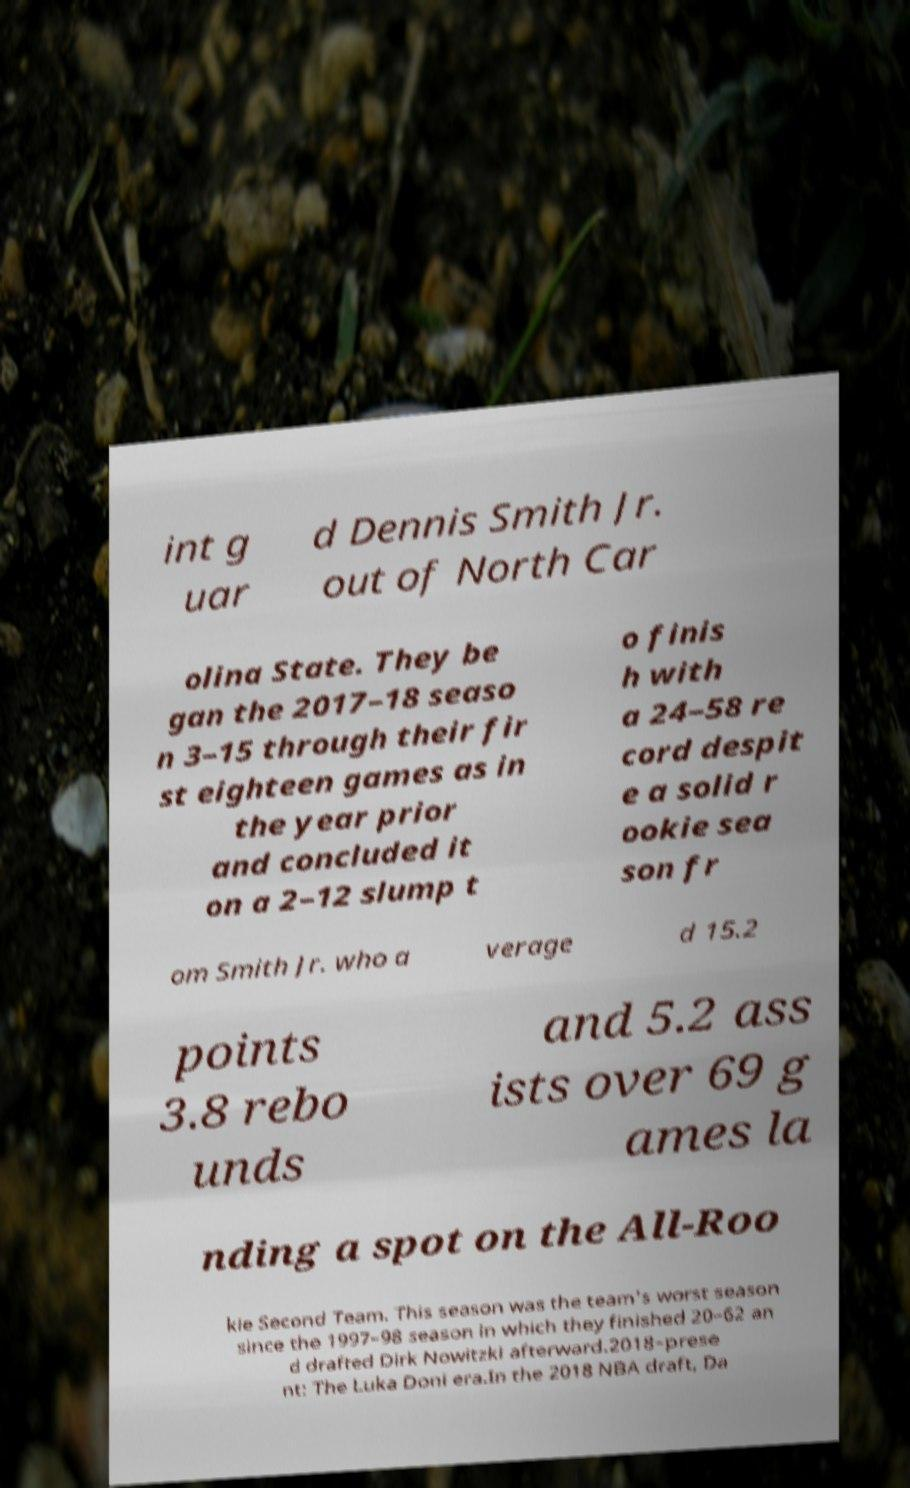There's text embedded in this image that I need extracted. Can you transcribe it verbatim? int g uar d Dennis Smith Jr. out of North Car olina State. They be gan the 2017–18 seaso n 3–15 through their fir st eighteen games as in the year prior and concluded it on a 2–12 slump t o finis h with a 24–58 re cord despit e a solid r ookie sea son fr om Smith Jr. who a verage d 15.2 points 3.8 rebo unds and 5.2 ass ists over 69 g ames la nding a spot on the All-Roo kie Second Team. This season was the team's worst season since the 1997–98 season in which they finished 20–62 an d drafted Dirk Nowitzki afterward.2018–prese nt: The Luka Doni era.In the 2018 NBA draft, Da 